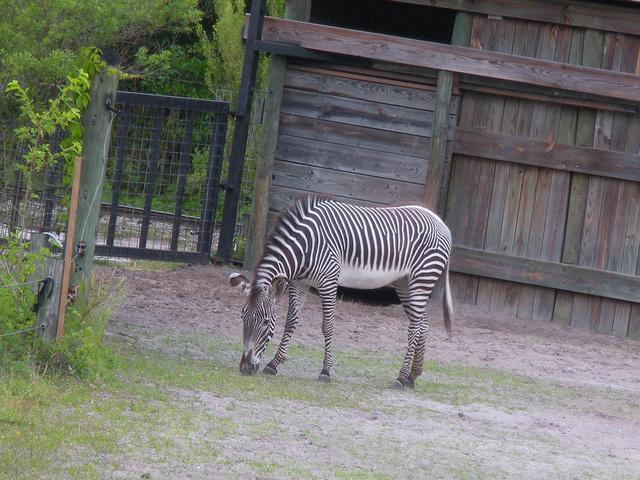How many creatures are in the photo?
Give a very brief answer. 1. How many different animals?
Give a very brief answer. 1. 